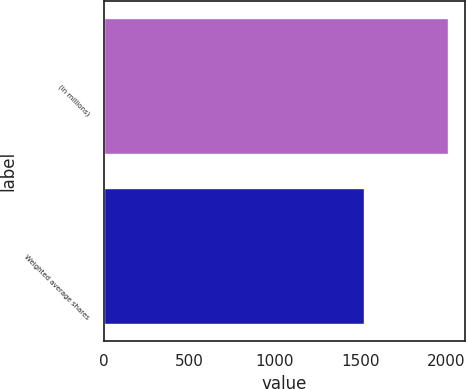Convert chart. <chart><loc_0><loc_0><loc_500><loc_500><bar_chart><fcel>(in millions)<fcel>Weighted average shares<nl><fcel>2010<fcel>1517.8<nl></chart> 